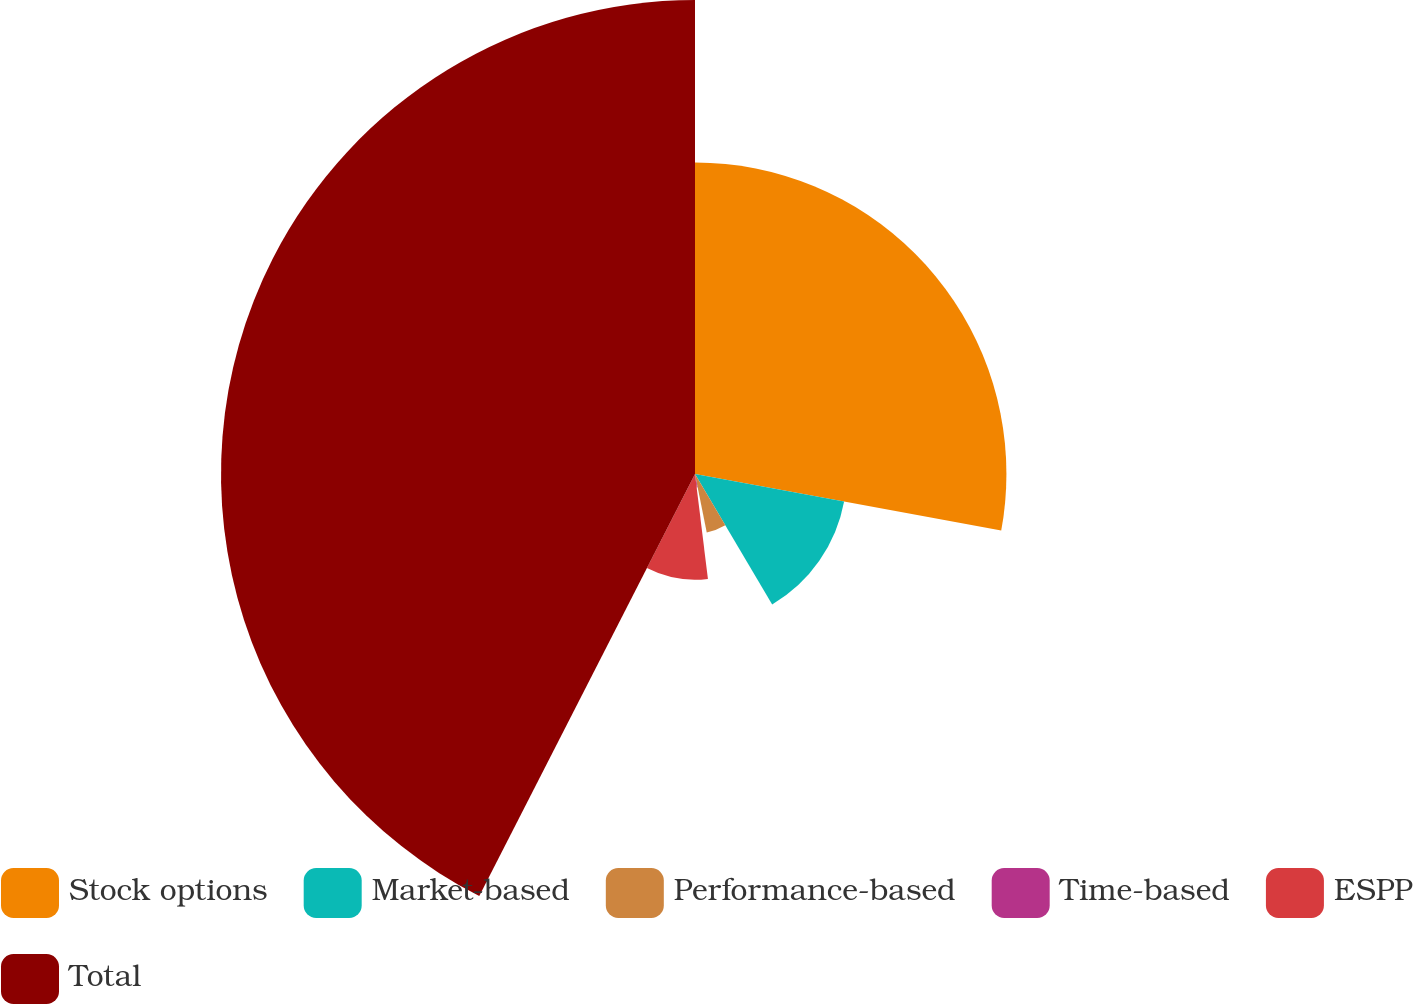<chart> <loc_0><loc_0><loc_500><loc_500><pie_chart><fcel>Stock options<fcel>Market-based<fcel>Performance-based<fcel>Time-based<fcel>ESPP<fcel>Total<nl><fcel>27.91%<fcel>13.59%<fcel>5.34%<fcel>1.21%<fcel>9.47%<fcel>42.48%<nl></chart> 